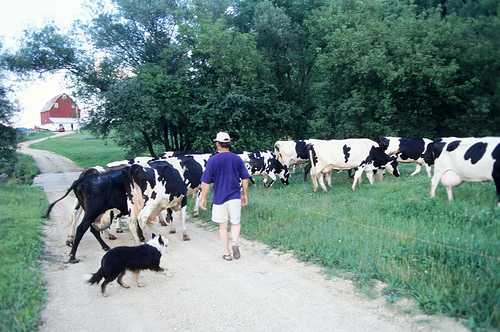<image>
Can you confirm if the barn is behind the cow? Yes. From this viewpoint, the barn is positioned behind the cow, with the cow partially or fully occluding the barn. Is there a cow behind the cow? Yes. From this viewpoint, the cow is positioned behind the cow, with the cow partially or fully occluding the cow. 